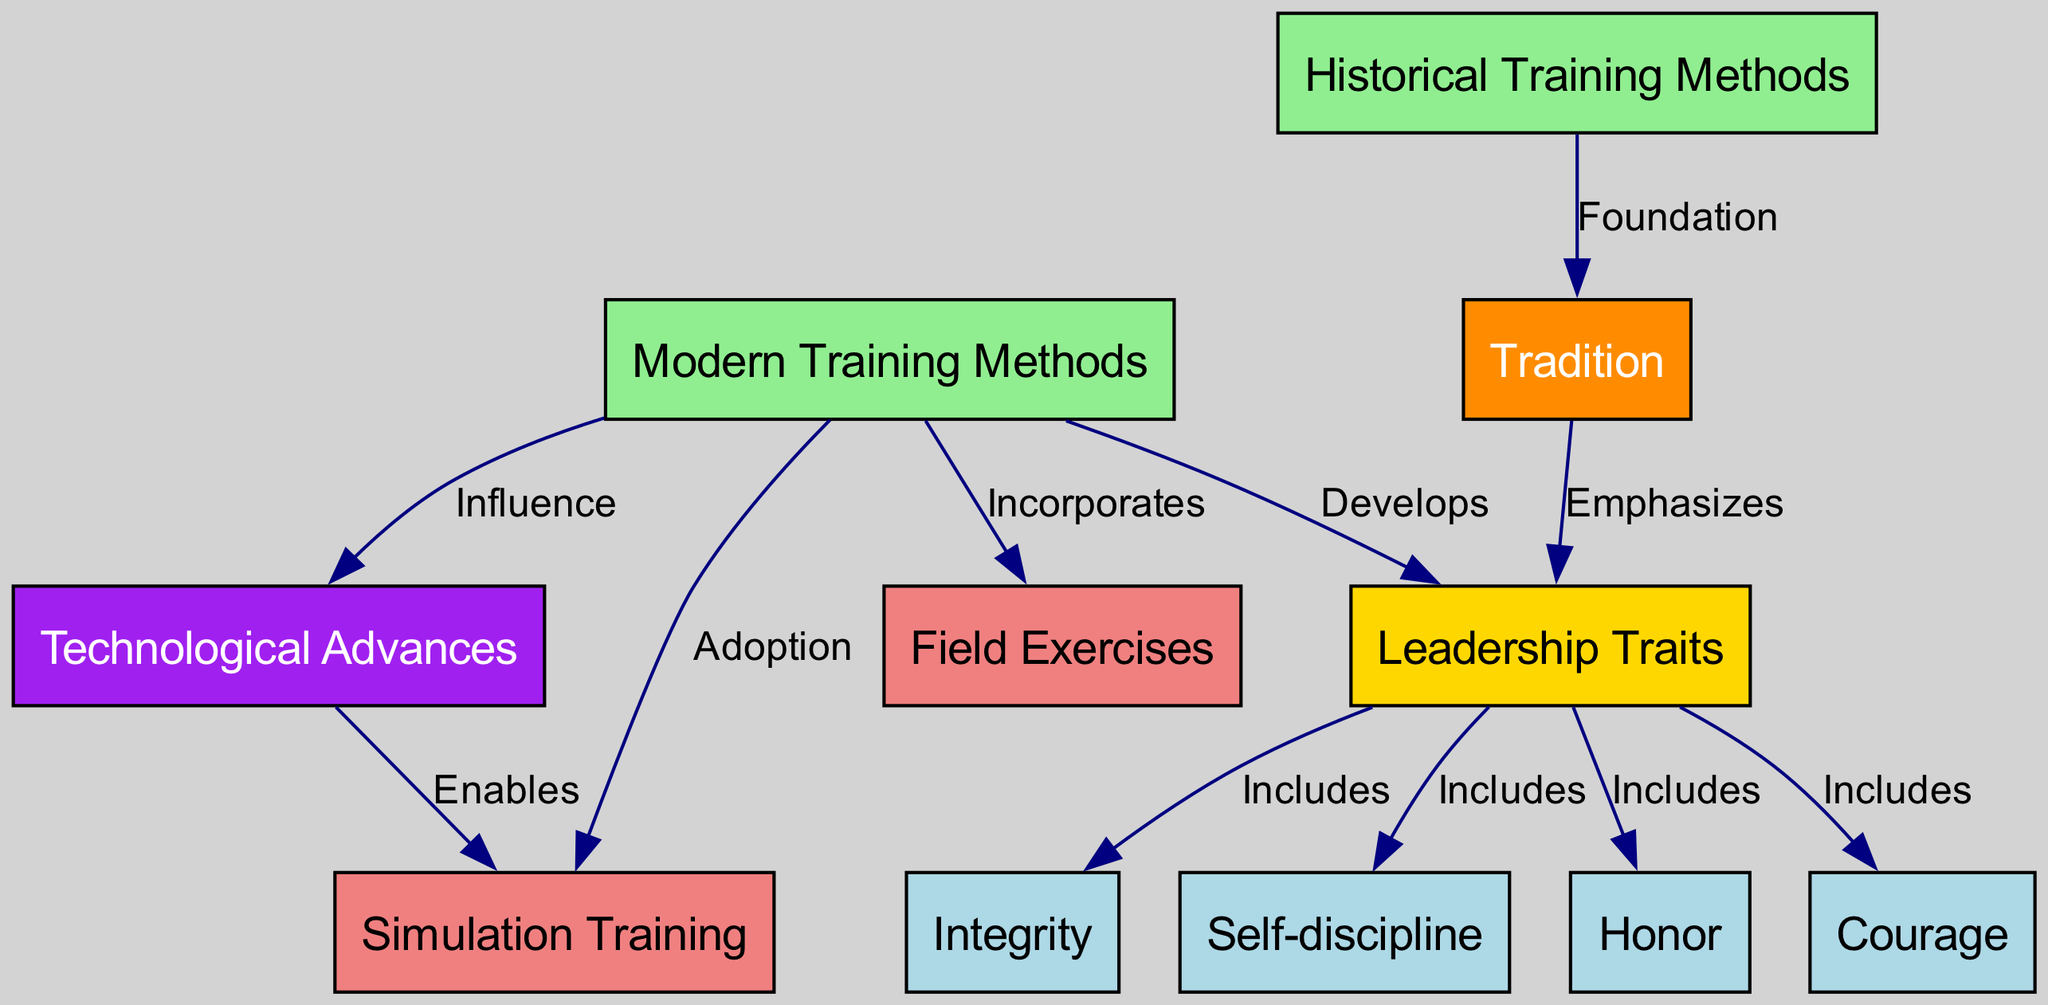What are the elements included in the leadership traits node? The leadership traits node includes several elements that are explicitly connected to it in the diagram, namely Honor, Courage, Integrity, and Self-discipline. These connections are indicated by the "Includes" relationship from the leadership traits node to each of these nodes.
Answer: Honor, Courage, Integrity, Self-discipline How many nodes are there in total in the diagram? To find the total number of nodes, I will count each unique node listed in the data. There are 11 unique nodes represented in the diagram.
Answer: 11 What does the "Foundation" label signify in the diagram? The "Foundation" label signifies the relationship from Historical Training Methods to Tradition. It indicates that historical training methods serve as a basis or foundational aspect for tradition in military training.
Answer: Foundation Which node is emphasized by Tradition? The node that is emphasized by Tradition is Leadership Traits. This is indicated by the edge labeled "Emphasizes," which points from Tradition to Leadership Traits, showing the importance of tradition in developing leadership traits.
Answer: Leadership Traits How does Modern Training Methods influence Technological Advances? The edge labeled "Influence" connects Modern Training Methods to Technological Advances, indicating that modern training methods have a significant impact on the development or utilization of technological advances in military training.
Answer: Influence What are the training methods incorporated by Modern Training Methods? Modern Training Methods incorporates Field Exercises and Simulation Training, as indicated by the edges labeled "Incorporates," connecting Modern Training Methods to both of these nodes.
Answer: Field Exercises, Simulation Training Which color represents Leadership Traits in the diagram? The color representing Leadership Traits in the diagram is gold, as it is specifically highlighted in the node's attributes defined during the diagram's creation process.
Answer: Gold How many edges connect to the Leadership Traits node? Counting the edges leading into the Leadership Traits node reveals there are 5 connections: from Honor, Courage, Integrity, Self-discipline, and Modern Training Methods.
Answer: 5 What role do Technological Advances play according to the diagram? Technological Advances enable Simulation Training, as indicated by the edge labeled "Enables" linking Technological Advances to Simulation Training, highlighting the role of technology in facilitating this type of training.
Answer: Enables 